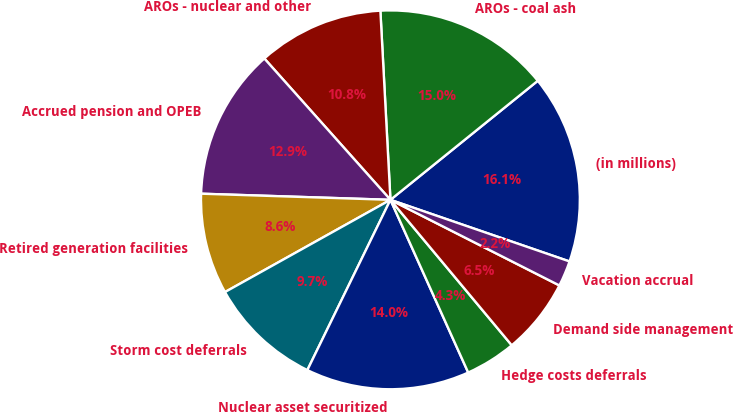Convert chart to OTSL. <chart><loc_0><loc_0><loc_500><loc_500><pie_chart><fcel>(in millions)<fcel>AROs - coal ash<fcel>AROs - nuclear and other<fcel>Accrued pension and OPEB<fcel>Retired generation facilities<fcel>Storm cost deferrals<fcel>Nuclear asset securitized<fcel>Hedge costs deferrals<fcel>Demand side management<fcel>Vacation accrual<nl><fcel>16.09%<fcel>15.03%<fcel>10.75%<fcel>12.89%<fcel>8.61%<fcel>9.68%<fcel>13.96%<fcel>4.33%<fcel>6.47%<fcel>2.19%<nl></chart> 